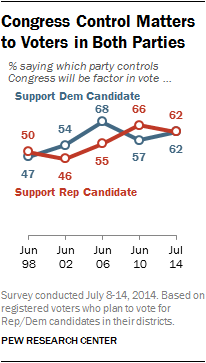Mention a couple of crucial points in this snapshot. The highest value of the blue graph is 68. The difference between the highest blue graph value and the highest red graph value is 2. 